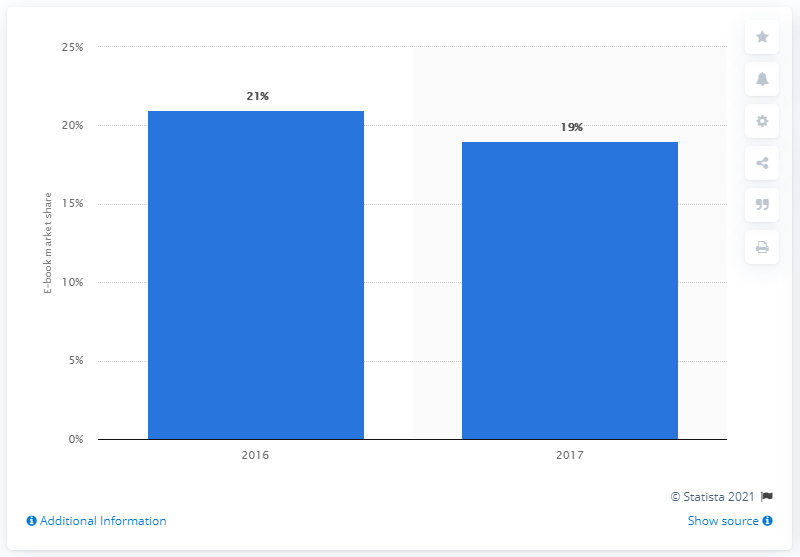Highlight a few significant elements in this photo. In 2017, approximately 19% of all book sales in the United States were electronic books. 